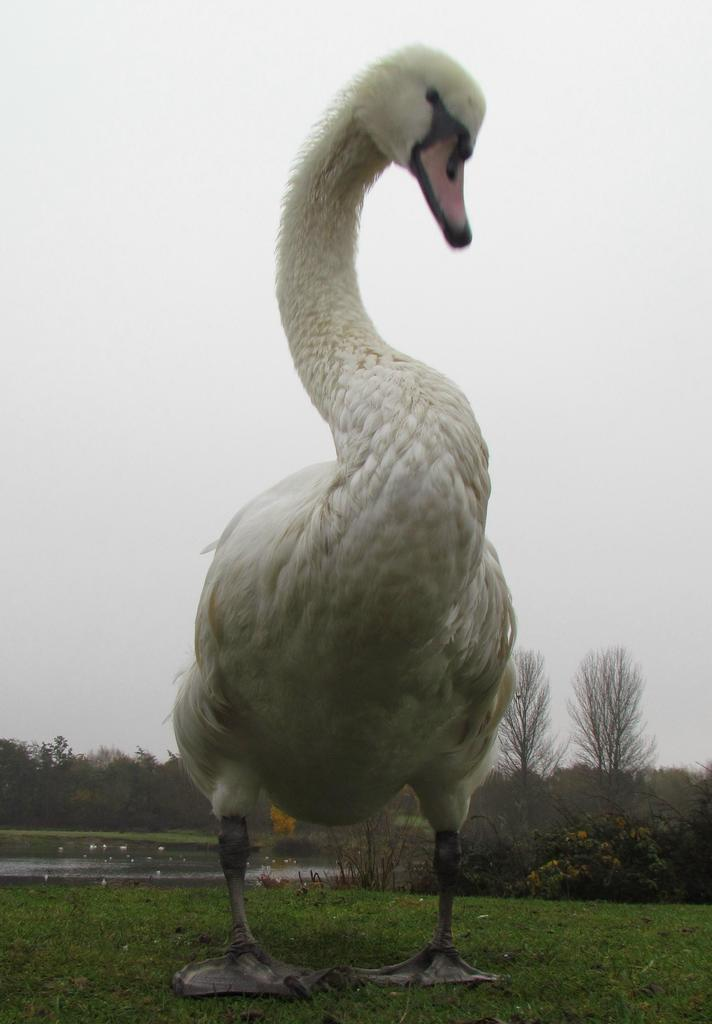What animal can be seen in the image? There is a duck in the image. Where is the duck located? The duck is standing on the grassland. What can be seen on the left side of the image? There is water on the left side of the image. What is visible in the background of the image? There are trees in the background of the image. What is visible at the top of the image? The sky is visible at the top of the image. What type of hospital can be seen in the background of the image? There is no hospital present in the image; it features a duck standing on grassland with water on the left side and trees in the background. 